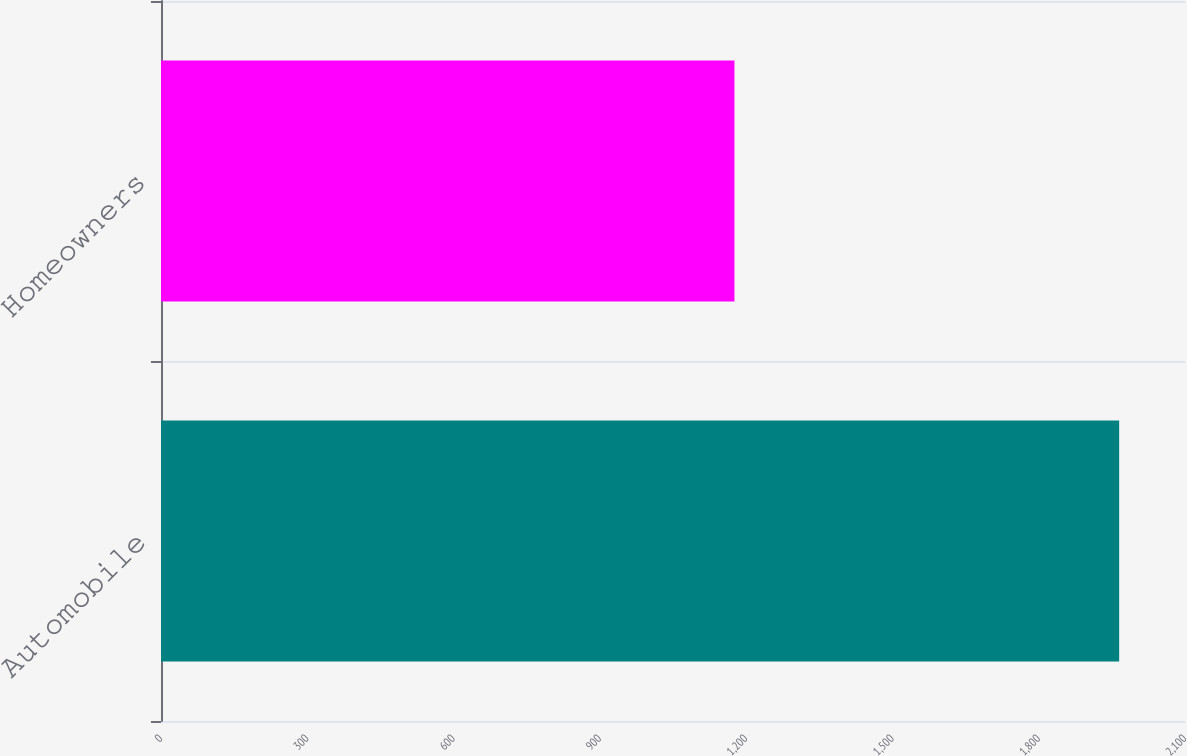Convert chart to OTSL. <chart><loc_0><loc_0><loc_500><loc_500><bar_chart><fcel>Automobile<fcel>Homeowners<nl><fcel>1965<fcel>1176<nl></chart> 